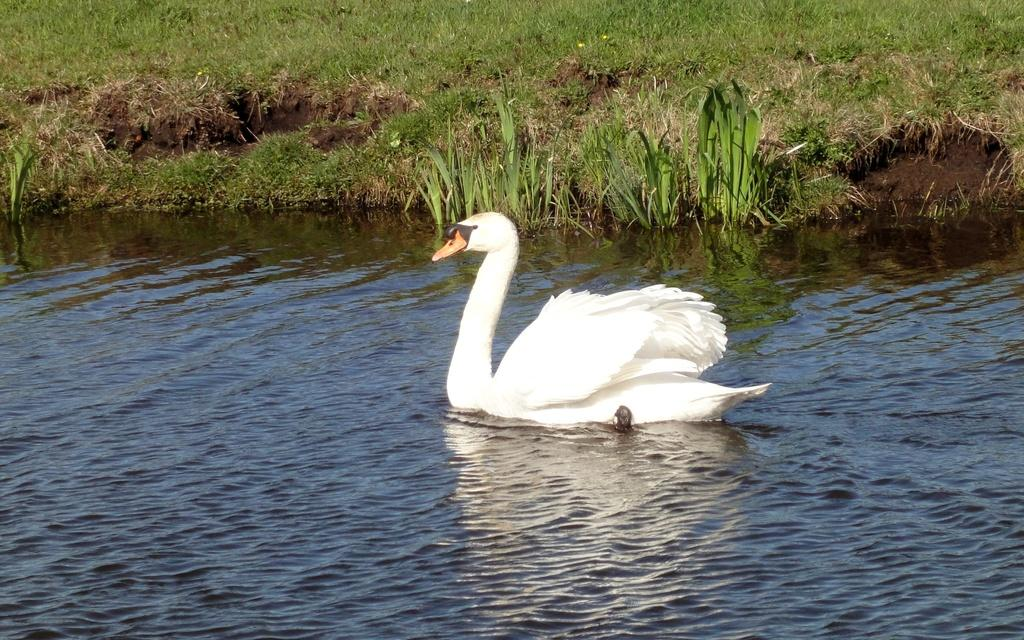What animal can be seen in the water in the image? There is a swan in the water in the image. What is the color of the grass in the image? The grass is green in color. Where is the yak grazing in the image? There is no yak present in the image. What type of clam is being served for lunch in the image? There is no lunch or clam present in the image. 